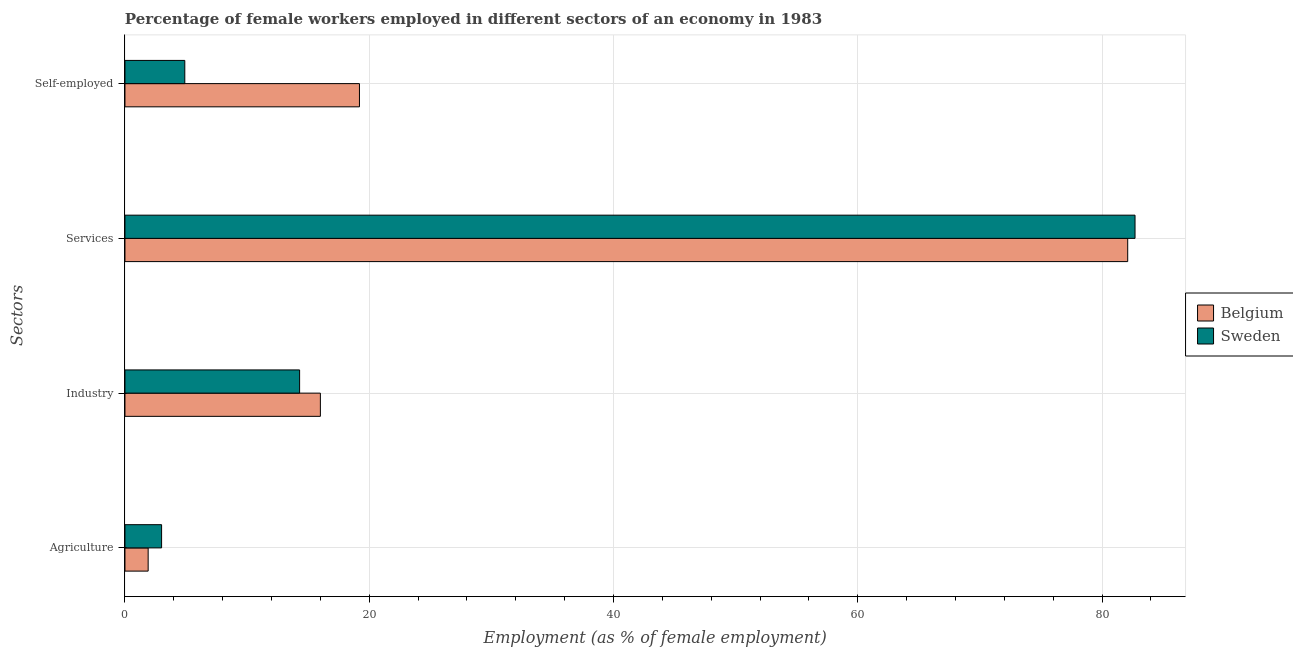Are the number of bars per tick equal to the number of legend labels?
Offer a very short reply. Yes. What is the label of the 1st group of bars from the top?
Make the answer very short. Self-employed. What is the percentage of female workers in agriculture in Belgium?
Offer a very short reply. 1.9. Across all countries, what is the maximum percentage of female workers in services?
Offer a very short reply. 82.7. Across all countries, what is the minimum percentage of female workers in industry?
Make the answer very short. 14.3. In which country was the percentage of female workers in services minimum?
Ensure brevity in your answer.  Belgium. What is the total percentage of female workers in industry in the graph?
Your answer should be compact. 30.3. What is the difference between the percentage of self employed female workers in Belgium and that in Sweden?
Provide a succinct answer. 14.3. What is the difference between the percentage of female workers in agriculture in Belgium and the percentage of female workers in services in Sweden?
Provide a succinct answer. -80.8. What is the average percentage of female workers in agriculture per country?
Provide a succinct answer. 2.45. What is the difference between the percentage of female workers in services and percentage of self employed female workers in Belgium?
Provide a succinct answer. 62.9. What is the ratio of the percentage of female workers in agriculture in Belgium to that in Sweden?
Provide a short and direct response. 0.63. Is the percentage of self employed female workers in Belgium less than that in Sweden?
Provide a short and direct response. No. Is the difference between the percentage of female workers in agriculture in Belgium and Sweden greater than the difference between the percentage of female workers in services in Belgium and Sweden?
Offer a very short reply. No. What is the difference between the highest and the second highest percentage of female workers in agriculture?
Your answer should be very brief. 1.1. What is the difference between the highest and the lowest percentage of female workers in agriculture?
Offer a terse response. 1.1. What does the 2nd bar from the top in Industry represents?
Keep it short and to the point. Belgium. What is the title of the graph?
Provide a succinct answer. Percentage of female workers employed in different sectors of an economy in 1983. What is the label or title of the X-axis?
Keep it short and to the point. Employment (as % of female employment). What is the label or title of the Y-axis?
Your answer should be compact. Sectors. What is the Employment (as % of female employment) in Belgium in Agriculture?
Keep it short and to the point. 1.9. What is the Employment (as % of female employment) in Sweden in Agriculture?
Give a very brief answer. 3. What is the Employment (as % of female employment) in Belgium in Industry?
Make the answer very short. 16. What is the Employment (as % of female employment) of Sweden in Industry?
Make the answer very short. 14.3. What is the Employment (as % of female employment) in Belgium in Services?
Your answer should be compact. 82.1. What is the Employment (as % of female employment) of Sweden in Services?
Provide a succinct answer. 82.7. What is the Employment (as % of female employment) of Belgium in Self-employed?
Offer a terse response. 19.2. What is the Employment (as % of female employment) of Sweden in Self-employed?
Offer a terse response. 4.9. Across all Sectors, what is the maximum Employment (as % of female employment) in Belgium?
Keep it short and to the point. 82.1. Across all Sectors, what is the maximum Employment (as % of female employment) of Sweden?
Ensure brevity in your answer.  82.7. Across all Sectors, what is the minimum Employment (as % of female employment) of Belgium?
Ensure brevity in your answer.  1.9. What is the total Employment (as % of female employment) in Belgium in the graph?
Keep it short and to the point. 119.2. What is the total Employment (as % of female employment) of Sweden in the graph?
Your response must be concise. 104.9. What is the difference between the Employment (as % of female employment) in Belgium in Agriculture and that in Industry?
Your answer should be compact. -14.1. What is the difference between the Employment (as % of female employment) of Sweden in Agriculture and that in Industry?
Your answer should be compact. -11.3. What is the difference between the Employment (as % of female employment) in Belgium in Agriculture and that in Services?
Your answer should be very brief. -80.2. What is the difference between the Employment (as % of female employment) of Sweden in Agriculture and that in Services?
Make the answer very short. -79.7. What is the difference between the Employment (as % of female employment) in Belgium in Agriculture and that in Self-employed?
Ensure brevity in your answer.  -17.3. What is the difference between the Employment (as % of female employment) in Belgium in Industry and that in Services?
Offer a terse response. -66.1. What is the difference between the Employment (as % of female employment) in Sweden in Industry and that in Services?
Provide a short and direct response. -68.4. What is the difference between the Employment (as % of female employment) in Sweden in Industry and that in Self-employed?
Provide a succinct answer. 9.4. What is the difference between the Employment (as % of female employment) in Belgium in Services and that in Self-employed?
Ensure brevity in your answer.  62.9. What is the difference between the Employment (as % of female employment) of Sweden in Services and that in Self-employed?
Give a very brief answer. 77.8. What is the difference between the Employment (as % of female employment) of Belgium in Agriculture and the Employment (as % of female employment) of Sweden in Industry?
Make the answer very short. -12.4. What is the difference between the Employment (as % of female employment) in Belgium in Agriculture and the Employment (as % of female employment) in Sweden in Services?
Ensure brevity in your answer.  -80.8. What is the difference between the Employment (as % of female employment) in Belgium in Industry and the Employment (as % of female employment) in Sweden in Services?
Provide a short and direct response. -66.7. What is the difference between the Employment (as % of female employment) in Belgium in Industry and the Employment (as % of female employment) in Sweden in Self-employed?
Ensure brevity in your answer.  11.1. What is the difference between the Employment (as % of female employment) of Belgium in Services and the Employment (as % of female employment) of Sweden in Self-employed?
Give a very brief answer. 77.2. What is the average Employment (as % of female employment) in Belgium per Sectors?
Keep it short and to the point. 29.8. What is the average Employment (as % of female employment) of Sweden per Sectors?
Keep it short and to the point. 26.23. What is the difference between the Employment (as % of female employment) in Belgium and Employment (as % of female employment) in Sweden in Industry?
Provide a succinct answer. 1.7. What is the difference between the Employment (as % of female employment) in Belgium and Employment (as % of female employment) in Sweden in Self-employed?
Give a very brief answer. 14.3. What is the ratio of the Employment (as % of female employment) of Belgium in Agriculture to that in Industry?
Your answer should be compact. 0.12. What is the ratio of the Employment (as % of female employment) of Sweden in Agriculture to that in Industry?
Offer a terse response. 0.21. What is the ratio of the Employment (as % of female employment) in Belgium in Agriculture to that in Services?
Offer a terse response. 0.02. What is the ratio of the Employment (as % of female employment) of Sweden in Agriculture to that in Services?
Provide a short and direct response. 0.04. What is the ratio of the Employment (as % of female employment) in Belgium in Agriculture to that in Self-employed?
Your answer should be very brief. 0.1. What is the ratio of the Employment (as % of female employment) of Sweden in Agriculture to that in Self-employed?
Your response must be concise. 0.61. What is the ratio of the Employment (as % of female employment) in Belgium in Industry to that in Services?
Provide a short and direct response. 0.19. What is the ratio of the Employment (as % of female employment) in Sweden in Industry to that in Services?
Make the answer very short. 0.17. What is the ratio of the Employment (as % of female employment) of Sweden in Industry to that in Self-employed?
Your answer should be very brief. 2.92. What is the ratio of the Employment (as % of female employment) of Belgium in Services to that in Self-employed?
Your answer should be compact. 4.28. What is the ratio of the Employment (as % of female employment) of Sweden in Services to that in Self-employed?
Make the answer very short. 16.88. What is the difference between the highest and the second highest Employment (as % of female employment) in Belgium?
Offer a terse response. 62.9. What is the difference between the highest and the second highest Employment (as % of female employment) of Sweden?
Your answer should be very brief. 68.4. What is the difference between the highest and the lowest Employment (as % of female employment) of Belgium?
Offer a terse response. 80.2. What is the difference between the highest and the lowest Employment (as % of female employment) in Sweden?
Your response must be concise. 79.7. 